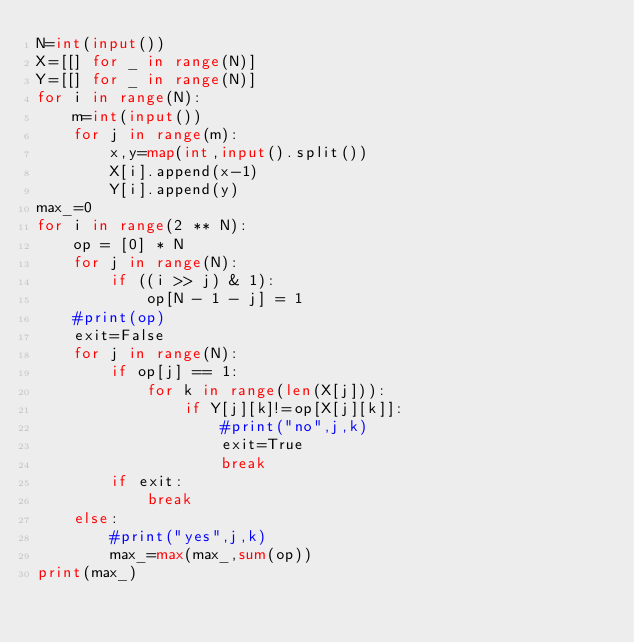<code> <loc_0><loc_0><loc_500><loc_500><_Python_>N=int(input())
X=[[] for _ in range(N)]
Y=[[] for _ in range(N)]
for i in range(N):
    m=int(input())
    for j in range(m):
        x,y=map(int,input().split())
        X[i].append(x-1)
        Y[i].append(y)
max_=0
for i in range(2 ** N):
    op = [0] * N  
    for j in range(N):
        if ((i >> j) & 1):
            op[N - 1 - j] = 1  
    #print(op)
    exit=False
    for j in range(N):
        if op[j] == 1:
            for k in range(len(X[j])):
                if Y[j][k]!=op[X[j][k]]:
                    #print("no",j,k)
                    exit=True
                    break
        if exit:
            break
    else:
        #print("yes",j,k)
        max_=max(max_,sum(op))
print(max_)</code> 